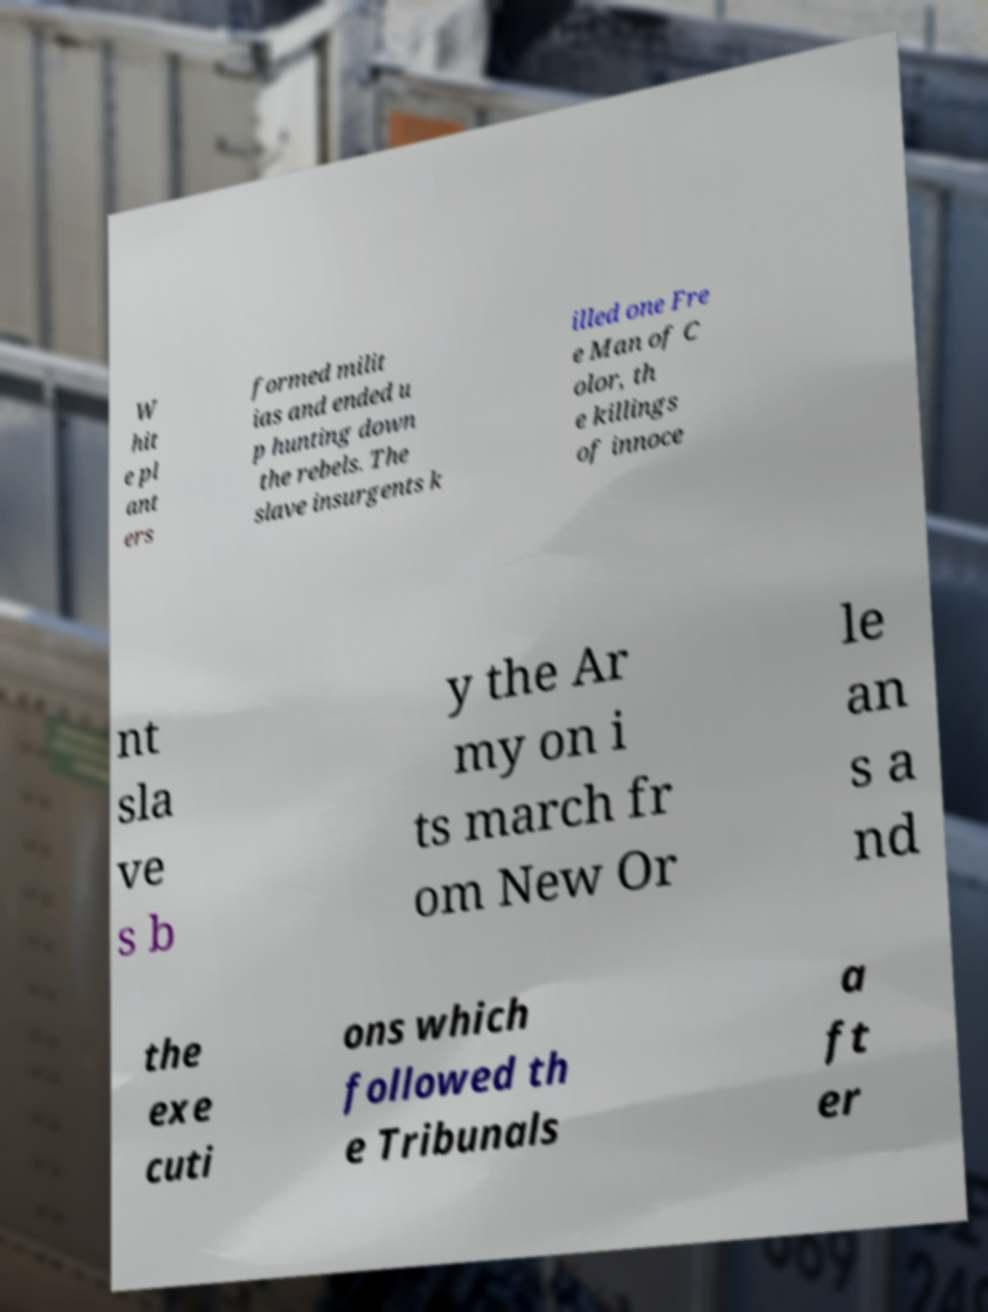Could you extract and type out the text from this image? W hit e pl ant ers formed milit ias and ended u p hunting down the rebels. The slave insurgents k illed one Fre e Man of C olor, th e killings of innoce nt sla ve s b y the Ar my on i ts march fr om New Or le an s a nd the exe cuti ons which followed th e Tribunals a ft er 